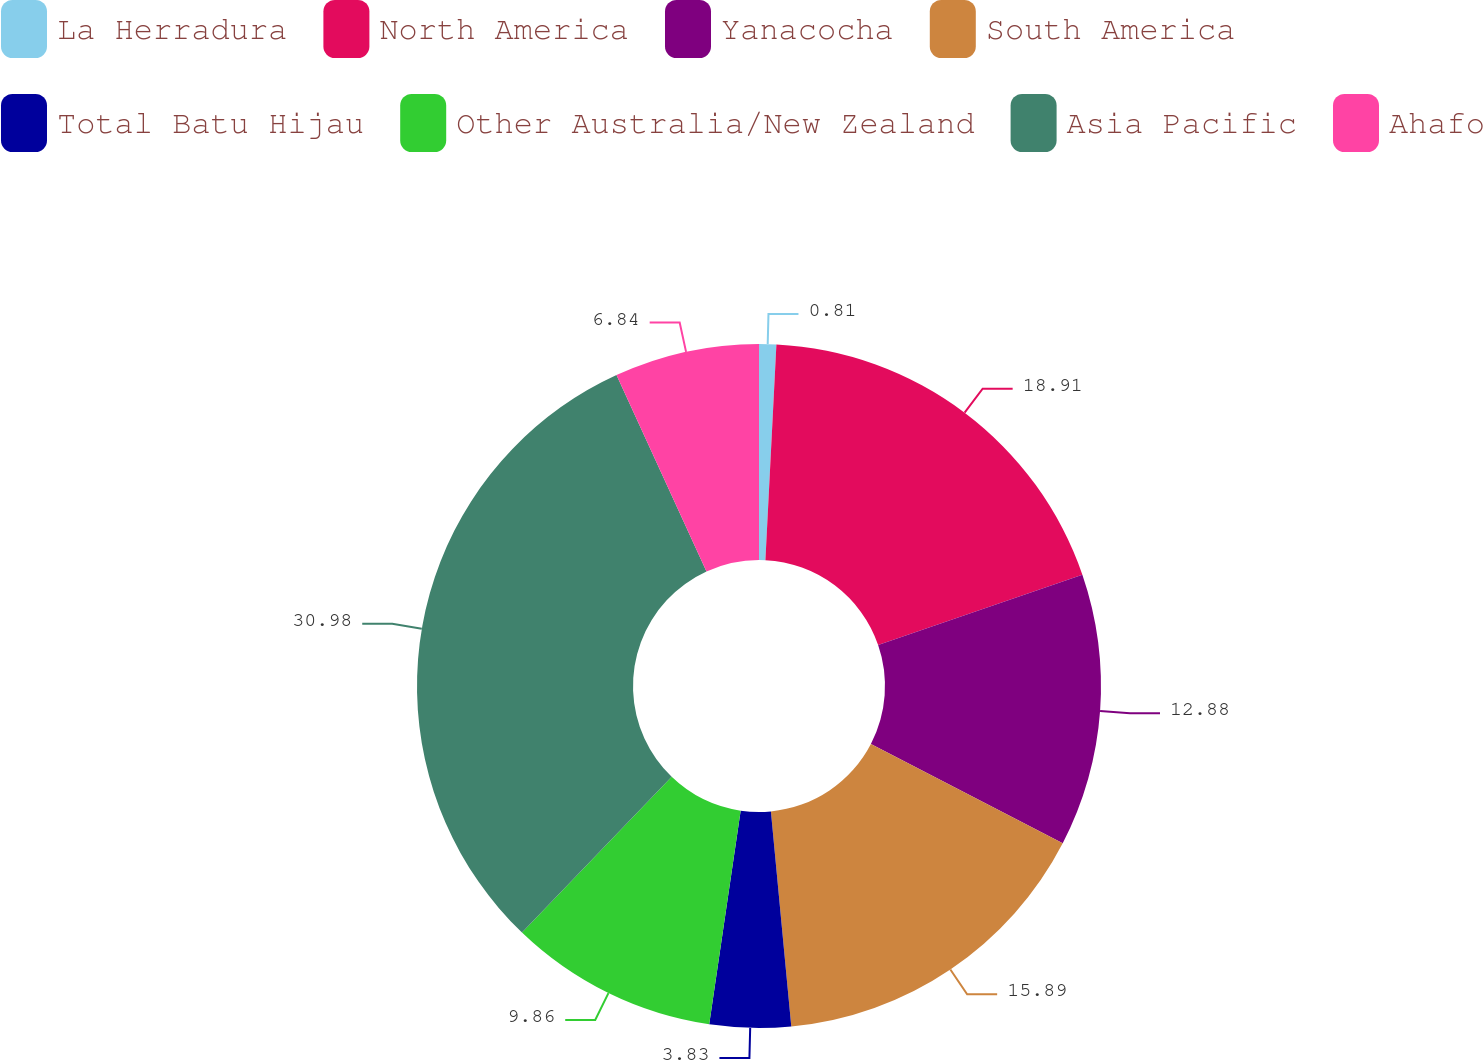Convert chart. <chart><loc_0><loc_0><loc_500><loc_500><pie_chart><fcel>La Herradura<fcel>North America<fcel>Yanacocha<fcel>South America<fcel>Total Batu Hijau<fcel>Other Australia/New Zealand<fcel>Asia Pacific<fcel>Ahafo<nl><fcel>0.81%<fcel>18.91%<fcel>12.88%<fcel>15.89%<fcel>3.83%<fcel>9.86%<fcel>30.97%<fcel>6.84%<nl></chart> 